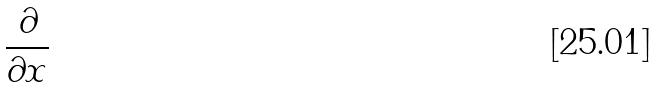<formula> <loc_0><loc_0><loc_500><loc_500>\frac { \partial } { \partial x }</formula> 